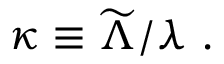<formula> <loc_0><loc_0><loc_500><loc_500>\kappa \equiv \widetilde { \Lambda } / \lambda .</formula> 